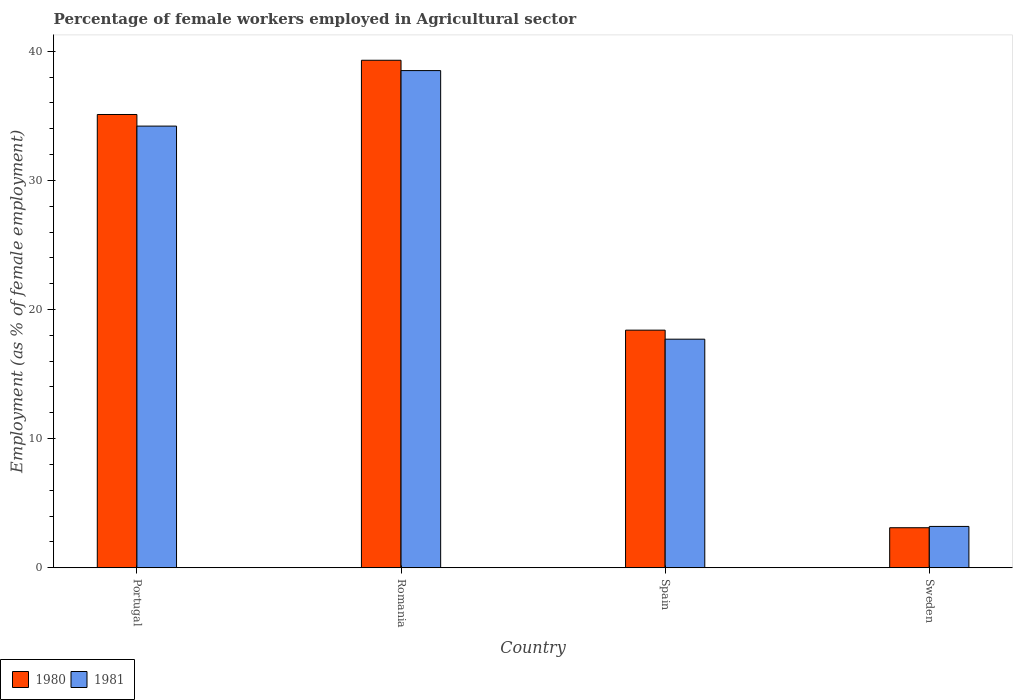How many different coloured bars are there?
Your answer should be compact. 2. How many groups of bars are there?
Your answer should be compact. 4. Are the number of bars on each tick of the X-axis equal?
Your response must be concise. Yes. How many bars are there on the 2nd tick from the right?
Ensure brevity in your answer.  2. What is the label of the 3rd group of bars from the left?
Ensure brevity in your answer.  Spain. What is the percentage of females employed in Agricultural sector in 1981 in Spain?
Offer a terse response. 17.7. Across all countries, what is the maximum percentage of females employed in Agricultural sector in 1981?
Your response must be concise. 38.5. Across all countries, what is the minimum percentage of females employed in Agricultural sector in 1980?
Your answer should be compact. 3.1. In which country was the percentage of females employed in Agricultural sector in 1981 maximum?
Your answer should be compact. Romania. What is the total percentage of females employed in Agricultural sector in 1981 in the graph?
Provide a short and direct response. 93.6. What is the difference between the percentage of females employed in Agricultural sector in 1980 in Portugal and that in Spain?
Provide a succinct answer. 16.7. What is the difference between the percentage of females employed in Agricultural sector in 1981 in Portugal and the percentage of females employed in Agricultural sector in 1980 in Spain?
Your answer should be compact. 15.8. What is the average percentage of females employed in Agricultural sector in 1980 per country?
Give a very brief answer. 23.97. What is the difference between the percentage of females employed in Agricultural sector of/in 1981 and percentage of females employed in Agricultural sector of/in 1980 in Romania?
Provide a short and direct response. -0.8. What is the ratio of the percentage of females employed in Agricultural sector in 1980 in Portugal to that in Sweden?
Provide a succinct answer. 11.32. Is the percentage of females employed in Agricultural sector in 1980 in Portugal less than that in Spain?
Offer a very short reply. No. Is the difference between the percentage of females employed in Agricultural sector in 1981 in Romania and Spain greater than the difference between the percentage of females employed in Agricultural sector in 1980 in Romania and Spain?
Your answer should be very brief. No. What is the difference between the highest and the second highest percentage of females employed in Agricultural sector in 1980?
Your answer should be very brief. -16.7. What is the difference between the highest and the lowest percentage of females employed in Agricultural sector in 1981?
Provide a succinct answer. 35.3. What does the 2nd bar from the left in Spain represents?
Keep it short and to the point. 1981. What does the 1st bar from the right in Portugal represents?
Give a very brief answer. 1981. How many bars are there?
Provide a short and direct response. 8. Are all the bars in the graph horizontal?
Your answer should be compact. No. What is the difference between two consecutive major ticks on the Y-axis?
Keep it short and to the point. 10. Are the values on the major ticks of Y-axis written in scientific E-notation?
Your response must be concise. No. Where does the legend appear in the graph?
Your answer should be very brief. Bottom left. How many legend labels are there?
Make the answer very short. 2. What is the title of the graph?
Keep it short and to the point. Percentage of female workers employed in Agricultural sector. Does "1968" appear as one of the legend labels in the graph?
Ensure brevity in your answer.  No. What is the label or title of the Y-axis?
Make the answer very short. Employment (as % of female employment). What is the Employment (as % of female employment) of 1980 in Portugal?
Offer a very short reply. 35.1. What is the Employment (as % of female employment) in 1981 in Portugal?
Offer a very short reply. 34.2. What is the Employment (as % of female employment) of 1980 in Romania?
Keep it short and to the point. 39.3. What is the Employment (as % of female employment) of 1981 in Romania?
Your answer should be very brief. 38.5. What is the Employment (as % of female employment) of 1980 in Spain?
Offer a very short reply. 18.4. What is the Employment (as % of female employment) of 1981 in Spain?
Provide a succinct answer. 17.7. What is the Employment (as % of female employment) of 1980 in Sweden?
Your answer should be very brief. 3.1. What is the Employment (as % of female employment) of 1981 in Sweden?
Keep it short and to the point. 3.2. Across all countries, what is the maximum Employment (as % of female employment) in 1980?
Keep it short and to the point. 39.3. Across all countries, what is the maximum Employment (as % of female employment) in 1981?
Your response must be concise. 38.5. Across all countries, what is the minimum Employment (as % of female employment) in 1980?
Make the answer very short. 3.1. Across all countries, what is the minimum Employment (as % of female employment) in 1981?
Make the answer very short. 3.2. What is the total Employment (as % of female employment) in 1980 in the graph?
Your response must be concise. 95.9. What is the total Employment (as % of female employment) in 1981 in the graph?
Your response must be concise. 93.6. What is the difference between the Employment (as % of female employment) in 1980 in Portugal and that in Spain?
Offer a terse response. 16.7. What is the difference between the Employment (as % of female employment) of 1981 in Portugal and that in Spain?
Provide a succinct answer. 16.5. What is the difference between the Employment (as % of female employment) of 1980 in Portugal and that in Sweden?
Keep it short and to the point. 32. What is the difference between the Employment (as % of female employment) in 1981 in Portugal and that in Sweden?
Offer a very short reply. 31. What is the difference between the Employment (as % of female employment) in 1980 in Romania and that in Spain?
Keep it short and to the point. 20.9. What is the difference between the Employment (as % of female employment) of 1981 in Romania and that in Spain?
Your answer should be very brief. 20.8. What is the difference between the Employment (as % of female employment) of 1980 in Romania and that in Sweden?
Your response must be concise. 36.2. What is the difference between the Employment (as % of female employment) in 1981 in Romania and that in Sweden?
Your answer should be very brief. 35.3. What is the difference between the Employment (as % of female employment) in 1980 in Portugal and the Employment (as % of female employment) in 1981 in Romania?
Your response must be concise. -3.4. What is the difference between the Employment (as % of female employment) of 1980 in Portugal and the Employment (as % of female employment) of 1981 in Sweden?
Your answer should be very brief. 31.9. What is the difference between the Employment (as % of female employment) in 1980 in Romania and the Employment (as % of female employment) in 1981 in Spain?
Make the answer very short. 21.6. What is the difference between the Employment (as % of female employment) of 1980 in Romania and the Employment (as % of female employment) of 1981 in Sweden?
Provide a succinct answer. 36.1. What is the difference between the Employment (as % of female employment) in 1980 in Spain and the Employment (as % of female employment) in 1981 in Sweden?
Offer a terse response. 15.2. What is the average Employment (as % of female employment) in 1980 per country?
Offer a very short reply. 23.98. What is the average Employment (as % of female employment) in 1981 per country?
Keep it short and to the point. 23.4. What is the difference between the Employment (as % of female employment) in 1980 and Employment (as % of female employment) in 1981 in Romania?
Offer a very short reply. 0.8. What is the difference between the Employment (as % of female employment) of 1980 and Employment (as % of female employment) of 1981 in Spain?
Provide a short and direct response. 0.7. What is the ratio of the Employment (as % of female employment) of 1980 in Portugal to that in Romania?
Your answer should be very brief. 0.89. What is the ratio of the Employment (as % of female employment) of 1981 in Portugal to that in Romania?
Your response must be concise. 0.89. What is the ratio of the Employment (as % of female employment) of 1980 in Portugal to that in Spain?
Provide a succinct answer. 1.91. What is the ratio of the Employment (as % of female employment) in 1981 in Portugal to that in Spain?
Offer a very short reply. 1.93. What is the ratio of the Employment (as % of female employment) in 1980 in Portugal to that in Sweden?
Provide a short and direct response. 11.32. What is the ratio of the Employment (as % of female employment) in 1981 in Portugal to that in Sweden?
Keep it short and to the point. 10.69. What is the ratio of the Employment (as % of female employment) of 1980 in Romania to that in Spain?
Provide a short and direct response. 2.14. What is the ratio of the Employment (as % of female employment) of 1981 in Romania to that in Spain?
Make the answer very short. 2.18. What is the ratio of the Employment (as % of female employment) of 1980 in Romania to that in Sweden?
Offer a terse response. 12.68. What is the ratio of the Employment (as % of female employment) in 1981 in Romania to that in Sweden?
Provide a succinct answer. 12.03. What is the ratio of the Employment (as % of female employment) in 1980 in Spain to that in Sweden?
Your response must be concise. 5.94. What is the ratio of the Employment (as % of female employment) in 1981 in Spain to that in Sweden?
Keep it short and to the point. 5.53. What is the difference between the highest and the lowest Employment (as % of female employment) of 1980?
Your answer should be compact. 36.2. What is the difference between the highest and the lowest Employment (as % of female employment) of 1981?
Ensure brevity in your answer.  35.3. 